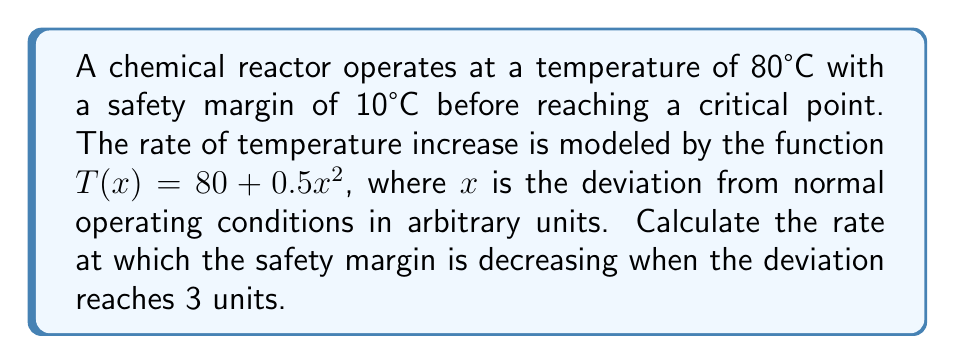Can you solve this math problem? To solve this problem, we need to follow these steps:

1) First, we identify the safety margin function. The safety margin (S) is the difference between the critical temperature (90°C) and the current temperature:

   $S(x) = 90 - T(x) = 90 - (80 + 0.5x^2) = 10 - 0.5x^2$

2) To find the rate at which the safety margin is decreasing, we need to find the derivative of S(x) with respect to x:

   $\frac{dS}{dx} = \frac{d}{dx}(10 - 0.5x^2) = -x$

3) The negative sign indicates that the safety margin is decreasing as x increases.

4) We're asked to evaluate this when the deviation reaches 3 units, so we substitute x = 3:

   $\frac{dS}{dx}\bigg|_{x=3} = -3$

5) This means that when the deviation is 3 units, the safety margin is decreasing at a rate of 3 units per unit change in x.
Answer: $-3$ units per unit change in deviation 